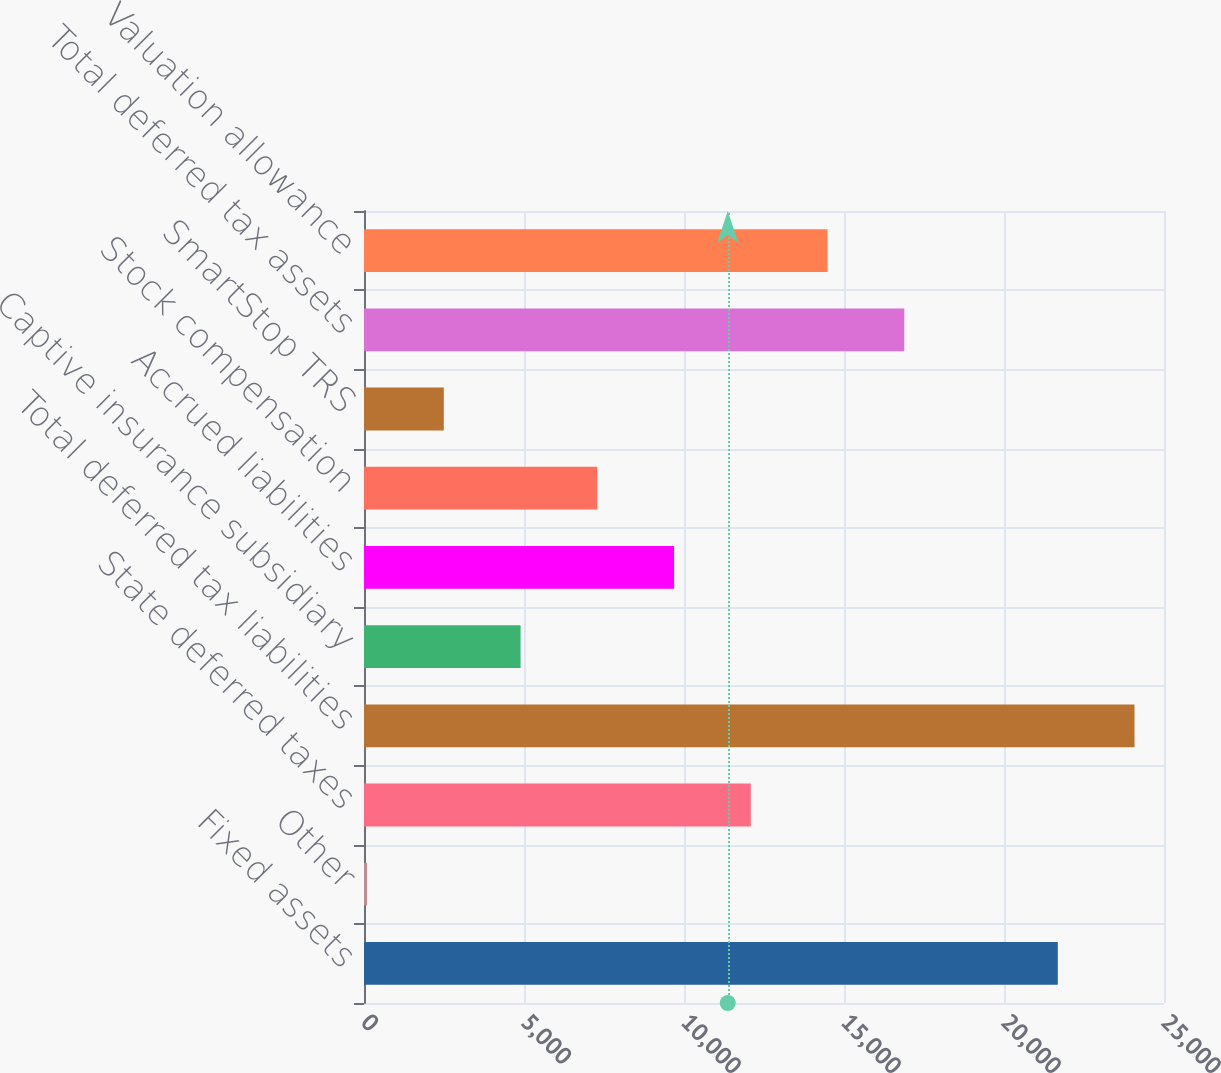Convert chart. <chart><loc_0><loc_0><loc_500><loc_500><bar_chart><fcel>Fixed assets<fcel>Other<fcel>State deferred taxes<fcel>Total deferred tax liabilities<fcel>Captive insurance subsidiary<fcel>Accrued liabilities<fcel>Stock compensation<fcel>SmartStop TRS<fcel>Total deferred tax assets<fcel>Valuation allowance<nl><fcel>21680.7<fcel>96<fcel>12087.5<fcel>24079<fcel>4892.6<fcel>9689.2<fcel>7290.9<fcel>2494.3<fcel>16884.1<fcel>14485.8<nl></chart> 